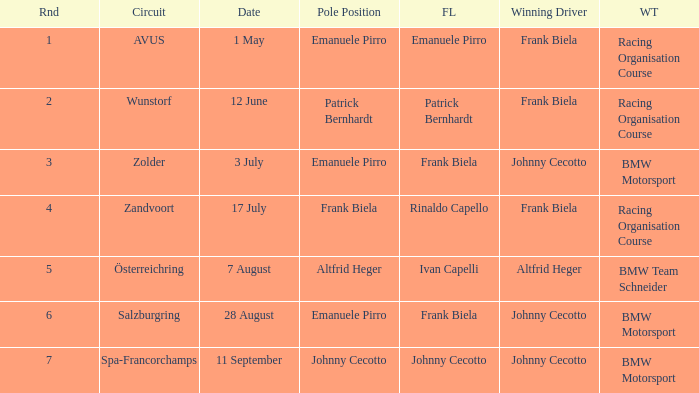Who was the winning team on the circuit Zolder? BMW Motorsport. 